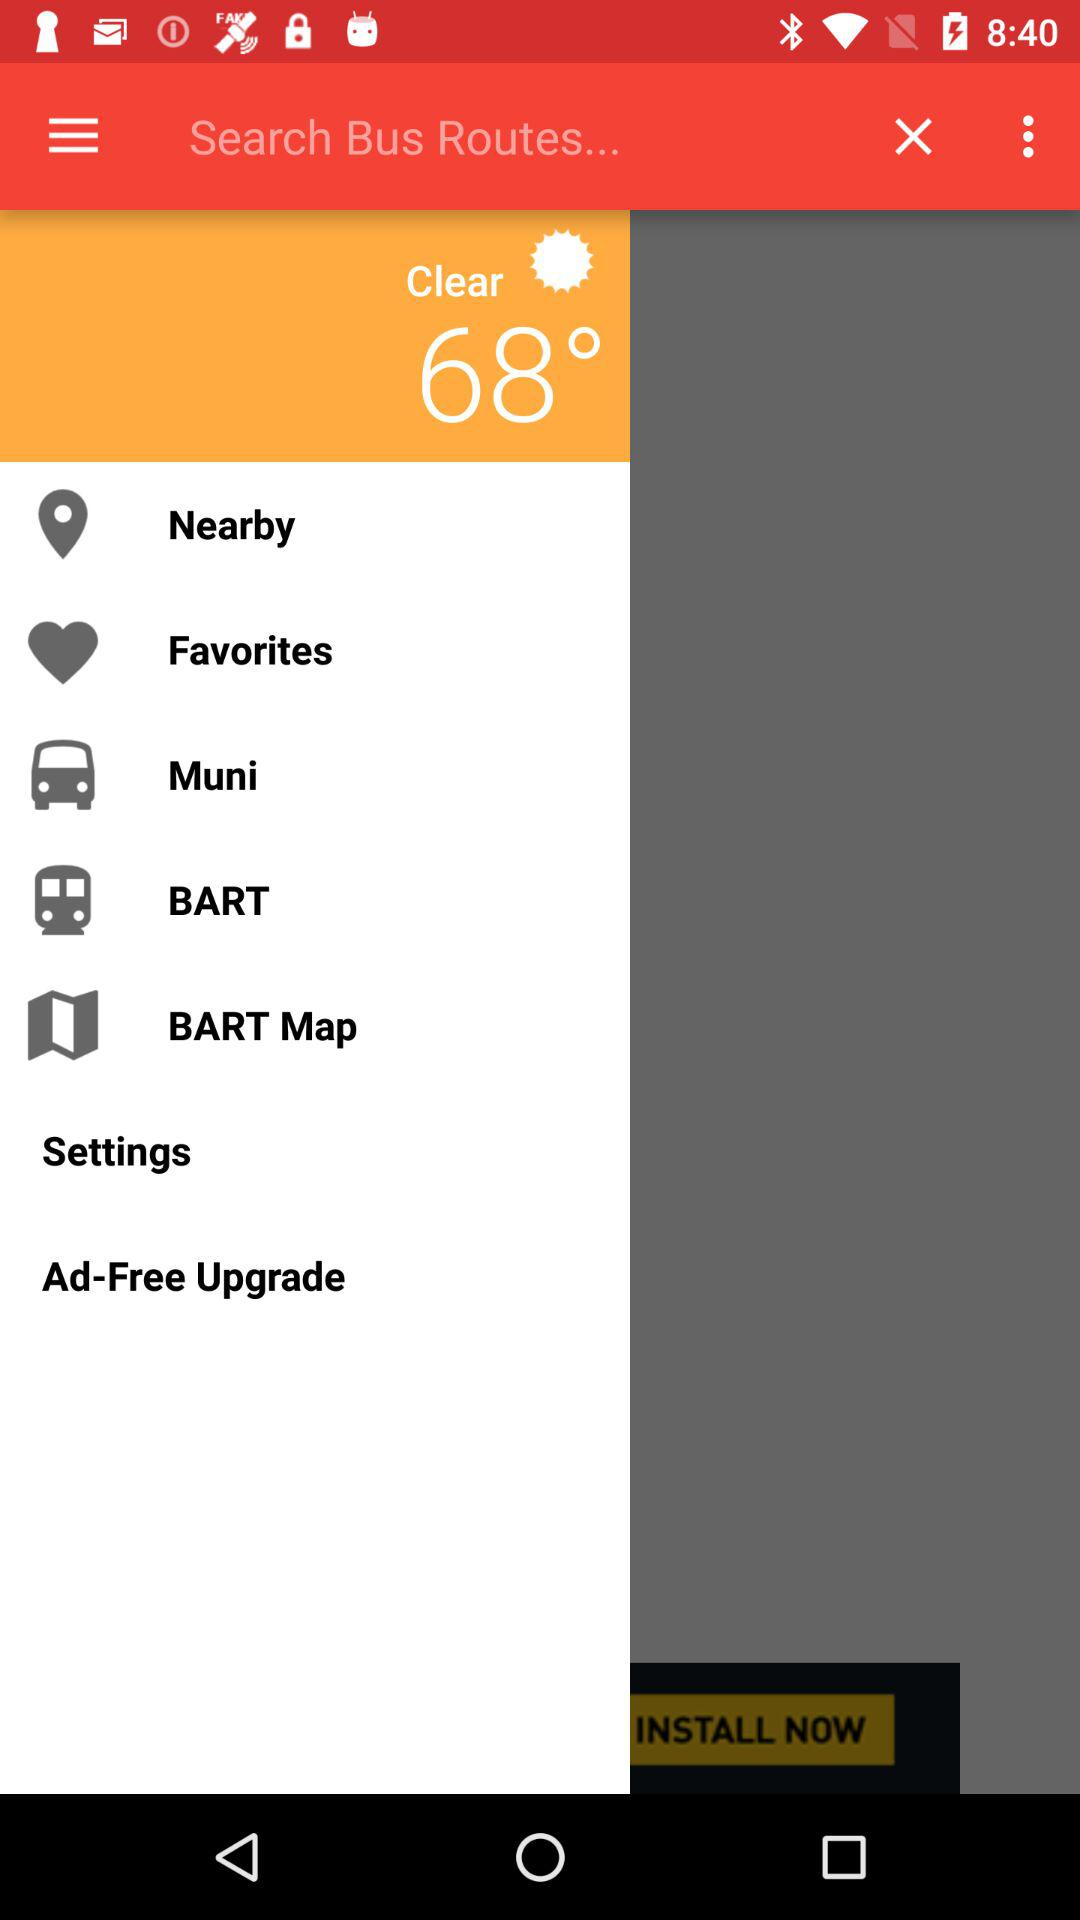What is the given temperature? The given temperature is 68 degrees. 